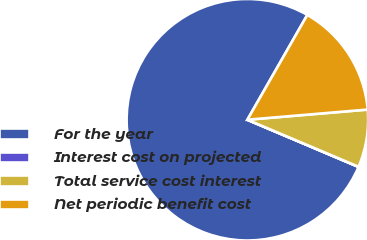Convert chart. <chart><loc_0><loc_0><loc_500><loc_500><pie_chart><fcel>For the year<fcel>Interest cost on projected<fcel>Total service cost interest<fcel>Net periodic benefit cost<nl><fcel>76.88%<fcel>0.02%<fcel>7.71%<fcel>15.39%<nl></chart> 